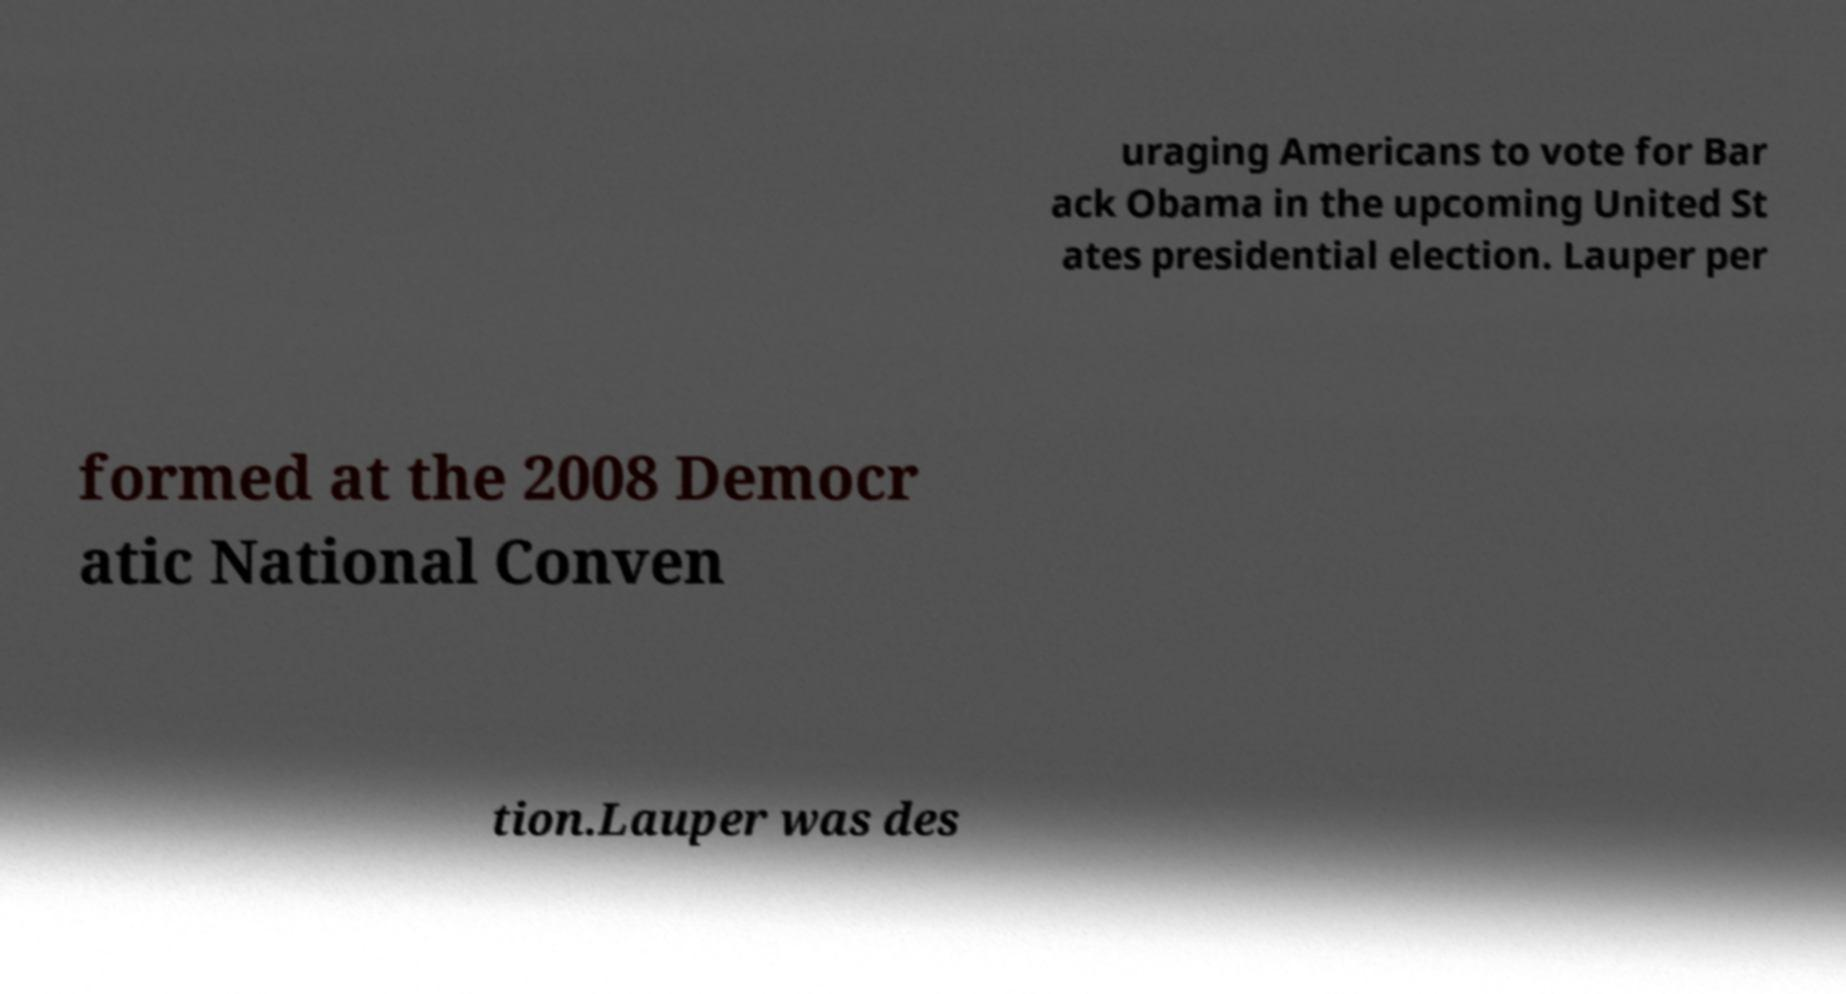Can you read and provide the text displayed in the image?This photo seems to have some interesting text. Can you extract and type it out for me? uraging Americans to vote for Bar ack Obama in the upcoming United St ates presidential election. Lauper per formed at the 2008 Democr atic National Conven tion.Lauper was des 